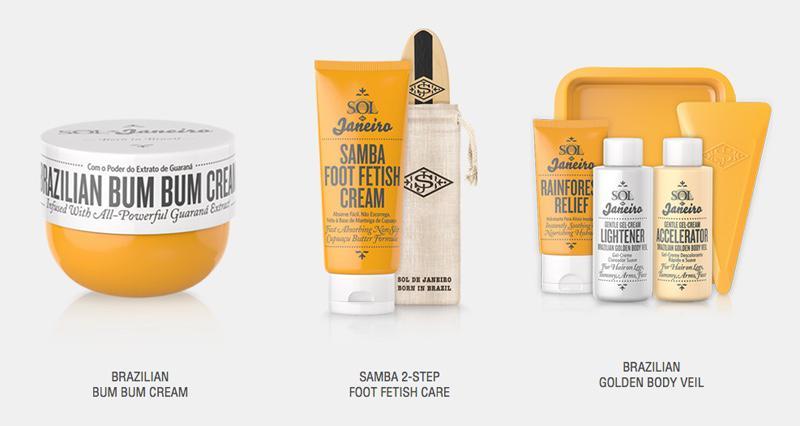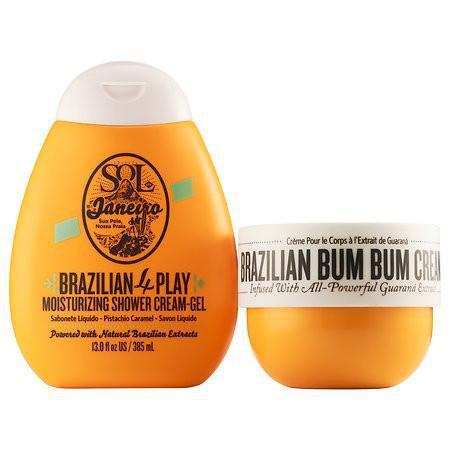The first image is the image on the left, the second image is the image on the right. Assess this claim about the two images: "One of the images contains only a single orange squeeze tube with a white cap.". Correct or not? Answer yes or no. No. 